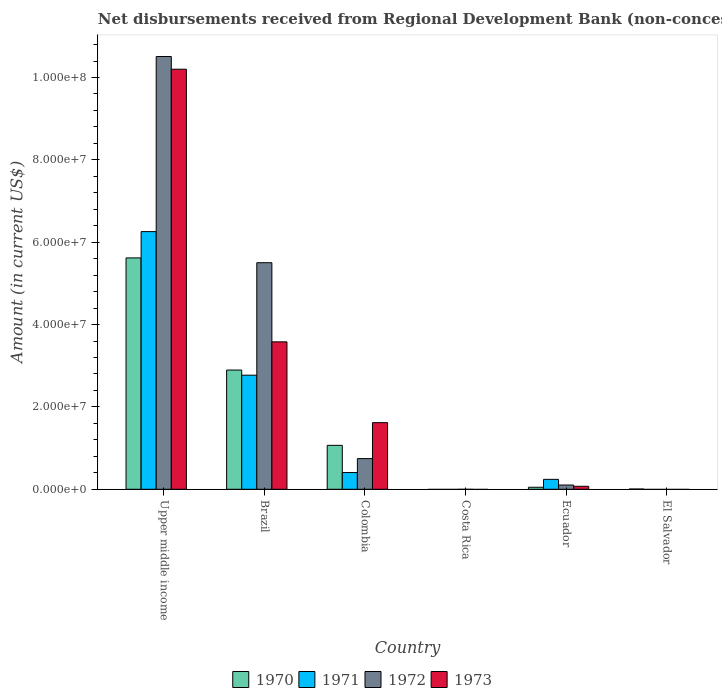Are the number of bars per tick equal to the number of legend labels?
Ensure brevity in your answer.  No. In how many cases, is the number of bars for a given country not equal to the number of legend labels?
Keep it short and to the point. 2. What is the amount of disbursements received from Regional Development Bank in 1970 in Upper middle income?
Ensure brevity in your answer.  5.62e+07. Across all countries, what is the maximum amount of disbursements received from Regional Development Bank in 1973?
Keep it short and to the point. 1.02e+08. In which country was the amount of disbursements received from Regional Development Bank in 1972 maximum?
Ensure brevity in your answer.  Upper middle income. What is the total amount of disbursements received from Regional Development Bank in 1973 in the graph?
Offer a terse response. 1.55e+08. What is the difference between the amount of disbursements received from Regional Development Bank in 1973 in Colombia and that in Ecuador?
Offer a very short reply. 1.55e+07. What is the difference between the amount of disbursements received from Regional Development Bank in 1971 in Colombia and the amount of disbursements received from Regional Development Bank in 1970 in Ecuador?
Your response must be concise. 3.57e+06. What is the average amount of disbursements received from Regional Development Bank in 1970 per country?
Give a very brief answer. 1.61e+07. What is the difference between the amount of disbursements received from Regional Development Bank of/in 1970 and amount of disbursements received from Regional Development Bank of/in 1971 in Ecuador?
Your answer should be very brief. -1.92e+06. What is the ratio of the amount of disbursements received from Regional Development Bank in 1972 in Brazil to that in Colombia?
Keep it short and to the point. 7.39. Is the amount of disbursements received from Regional Development Bank in 1972 in Brazil less than that in Ecuador?
Ensure brevity in your answer.  No. Is the difference between the amount of disbursements received from Regional Development Bank in 1970 in Colombia and Upper middle income greater than the difference between the amount of disbursements received from Regional Development Bank in 1971 in Colombia and Upper middle income?
Keep it short and to the point. Yes. What is the difference between the highest and the second highest amount of disbursements received from Regional Development Bank in 1970?
Provide a short and direct response. 4.55e+07. What is the difference between the highest and the lowest amount of disbursements received from Regional Development Bank in 1972?
Your answer should be very brief. 1.05e+08. Is it the case that in every country, the sum of the amount of disbursements received from Regional Development Bank in 1971 and amount of disbursements received from Regional Development Bank in 1970 is greater than the amount of disbursements received from Regional Development Bank in 1972?
Ensure brevity in your answer.  No. How many bars are there?
Offer a terse response. 17. How many countries are there in the graph?
Provide a succinct answer. 6. What is the difference between two consecutive major ticks on the Y-axis?
Make the answer very short. 2.00e+07. Does the graph contain any zero values?
Keep it short and to the point. Yes. Does the graph contain grids?
Offer a very short reply. No. How many legend labels are there?
Ensure brevity in your answer.  4. How are the legend labels stacked?
Give a very brief answer. Horizontal. What is the title of the graph?
Make the answer very short. Net disbursements received from Regional Development Bank (non-concessional). What is the label or title of the Y-axis?
Provide a short and direct response. Amount (in current US$). What is the Amount (in current US$) in 1970 in Upper middle income?
Your answer should be compact. 5.62e+07. What is the Amount (in current US$) of 1971 in Upper middle income?
Ensure brevity in your answer.  6.26e+07. What is the Amount (in current US$) of 1972 in Upper middle income?
Your answer should be very brief. 1.05e+08. What is the Amount (in current US$) in 1973 in Upper middle income?
Ensure brevity in your answer.  1.02e+08. What is the Amount (in current US$) in 1970 in Brazil?
Offer a terse response. 2.90e+07. What is the Amount (in current US$) in 1971 in Brazil?
Keep it short and to the point. 2.77e+07. What is the Amount (in current US$) of 1972 in Brazil?
Keep it short and to the point. 5.50e+07. What is the Amount (in current US$) in 1973 in Brazil?
Provide a succinct answer. 3.58e+07. What is the Amount (in current US$) of 1970 in Colombia?
Ensure brevity in your answer.  1.07e+07. What is the Amount (in current US$) of 1971 in Colombia?
Offer a terse response. 4.06e+06. What is the Amount (in current US$) of 1972 in Colombia?
Your answer should be very brief. 7.45e+06. What is the Amount (in current US$) in 1973 in Colombia?
Your answer should be very brief. 1.62e+07. What is the Amount (in current US$) in 1972 in Costa Rica?
Provide a succinct answer. 0. What is the Amount (in current US$) of 1973 in Costa Rica?
Offer a very short reply. 0. What is the Amount (in current US$) of 1970 in Ecuador?
Offer a very short reply. 4.89e+05. What is the Amount (in current US$) in 1971 in Ecuador?
Provide a short and direct response. 2.41e+06. What is the Amount (in current US$) of 1972 in Ecuador?
Your response must be concise. 1.03e+06. What is the Amount (in current US$) of 1973 in Ecuador?
Make the answer very short. 7.26e+05. What is the Amount (in current US$) in 1970 in El Salvador?
Offer a very short reply. 5.70e+04. What is the Amount (in current US$) of 1973 in El Salvador?
Your response must be concise. 0. Across all countries, what is the maximum Amount (in current US$) in 1970?
Your answer should be compact. 5.62e+07. Across all countries, what is the maximum Amount (in current US$) in 1971?
Offer a very short reply. 6.26e+07. Across all countries, what is the maximum Amount (in current US$) of 1972?
Make the answer very short. 1.05e+08. Across all countries, what is the maximum Amount (in current US$) of 1973?
Your answer should be compact. 1.02e+08. Across all countries, what is the minimum Amount (in current US$) of 1971?
Offer a terse response. 0. What is the total Amount (in current US$) of 1970 in the graph?
Your answer should be compact. 9.64e+07. What is the total Amount (in current US$) of 1971 in the graph?
Provide a short and direct response. 9.68e+07. What is the total Amount (in current US$) in 1972 in the graph?
Your answer should be compact. 1.69e+08. What is the total Amount (in current US$) of 1973 in the graph?
Your answer should be compact. 1.55e+08. What is the difference between the Amount (in current US$) in 1970 in Upper middle income and that in Brazil?
Provide a succinct answer. 2.72e+07. What is the difference between the Amount (in current US$) of 1971 in Upper middle income and that in Brazil?
Your answer should be very brief. 3.49e+07. What is the difference between the Amount (in current US$) in 1972 in Upper middle income and that in Brazil?
Your response must be concise. 5.01e+07. What is the difference between the Amount (in current US$) of 1973 in Upper middle income and that in Brazil?
Make the answer very short. 6.62e+07. What is the difference between the Amount (in current US$) of 1970 in Upper middle income and that in Colombia?
Make the answer very short. 4.55e+07. What is the difference between the Amount (in current US$) of 1971 in Upper middle income and that in Colombia?
Make the answer very short. 5.85e+07. What is the difference between the Amount (in current US$) in 1972 in Upper middle income and that in Colombia?
Provide a short and direct response. 9.76e+07. What is the difference between the Amount (in current US$) in 1973 in Upper middle income and that in Colombia?
Your answer should be very brief. 8.58e+07. What is the difference between the Amount (in current US$) of 1970 in Upper middle income and that in Ecuador?
Your answer should be very brief. 5.57e+07. What is the difference between the Amount (in current US$) in 1971 in Upper middle income and that in Ecuador?
Your answer should be compact. 6.02e+07. What is the difference between the Amount (in current US$) in 1972 in Upper middle income and that in Ecuador?
Your answer should be very brief. 1.04e+08. What is the difference between the Amount (in current US$) in 1973 in Upper middle income and that in Ecuador?
Give a very brief answer. 1.01e+08. What is the difference between the Amount (in current US$) of 1970 in Upper middle income and that in El Salvador?
Your answer should be very brief. 5.61e+07. What is the difference between the Amount (in current US$) in 1970 in Brazil and that in Colombia?
Provide a short and direct response. 1.83e+07. What is the difference between the Amount (in current US$) in 1971 in Brazil and that in Colombia?
Ensure brevity in your answer.  2.36e+07. What is the difference between the Amount (in current US$) in 1972 in Brazil and that in Colombia?
Your answer should be compact. 4.76e+07. What is the difference between the Amount (in current US$) in 1973 in Brazil and that in Colombia?
Offer a very short reply. 1.96e+07. What is the difference between the Amount (in current US$) in 1970 in Brazil and that in Ecuador?
Make the answer very short. 2.85e+07. What is the difference between the Amount (in current US$) of 1971 in Brazil and that in Ecuador?
Your response must be concise. 2.53e+07. What is the difference between the Amount (in current US$) of 1972 in Brazil and that in Ecuador?
Offer a very short reply. 5.40e+07. What is the difference between the Amount (in current US$) in 1973 in Brazil and that in Ecuador?
Ensure brevity in your answer.  3.51e+07. What is the difference between the Amount (in current US$) of 1970 in Brazil and that in El Salvador?
Your answer should be very brief. 2.89e+07. What is the difference between the Amount (in current US$) of 1970 in Colombia and that in Ecuador?
Make the answer very short. 1.02e+07. What is the difference between the Amount (in current US$) in 1971 in Colombia and that in Ecuador?
Provide a short and direct response. 1.65e+06. What is the difference between the Amount (in current US$) in 1972 in Colombia and that in Ecuador?
Keep it short and to the point. 6.42e+06. What is the difference between the Amount (in current US$) of 1973 in Colombia and that in Ecuador?
Provide a short and direct response. 1.55e+07. What is the difference between the Amount (in current US$) in 1970 in Colombia and that in El Salvador?
Provide a succinct answer. 1.06e+07. What is the difference between the Amount (in current US$) in 1970 in Ecuador and that in El Salvador?
Give a very brief answer. 4.32e+05. What is the difference between the Amount (in current US$) of 1970 in Upper middle income and the Amount (in current US$) of 1971 in Brazil?
Provide a succinct answer. 2.85e+07. What is the difference between the Amount (in current US$) of 1970 in Upper middle income and the Amount (in current US$) of 1972 in Brazil?
Offer a terse response. 1.16e+06. What is the difference between the Amount (in current US$) of 1970 in Upper middle income and the Amount (in current US$) of 1973 in Brazil?
Give a very brief answer. 2.04e+07. What is the difference between the Amount (in current US$) of 1971 in Upper middle income and the Amount (in current US$) of 1972 in Brazil?
Your response must be concise. 7.55e+06. What is the difference between the Amount (in current US$) in 1971 in Upper middle income and the Amount (in current US$) in 1973 in Brazil?
Keep it short and to the point. 2.68e+07. What is the difference between the Amount (in current US$) of 1972 in Upper middle income and the Amount (in current US$) of 1973 in Brazil?
Offer a very short reply. 6.93e+07. What is the difference between the Amount (in current US$) of 1970 in Upper middle income and the Amount (in current US$) of 1971 in Colombia?
Provide a succinct answer. 5.21e+07. What is the difference between the Amount (in current US$) in 1970 in Upper middle income and the Amount (in current US$) in 1972 in Colombia?
Make the answer very short. 4.87e+07. What is the difference between the Amount (in current US$) of 1970 in Upper middle income and the Amount (in current US$) of 1973 in Colombia?
Keep it short and to the point. 4.00e+07. What is the difference between the Amount (in current US$) in 1971 in Upper middle income and the Amount (in current US$) in 1972 in Colombia?
Give a very brief answer. 5.51e+07. What is the difference between the Amount (in current US$) in 1971 in Upper middle income and the Amount (in current US$) in 1973 in Colombia?
Make the answer very short. 4.64e+07. What is the difference between the Amount (in current US$) of 1972 in Upper middle income and the Amount (in current US$) of 1973 in Colombia?
Your answer should be compact. 8.89e+07. What is the difference between the Amount (in current US$) in 1970 in Upper middle income and the Amount (in current US$) in 1971 in Ecuador?
Your response must be concise. 5.38e+07. What is the difference between the Amount (in current US$) in 1970 in Upper middle income and the Amount (in current US$) in 1972 in Ecuador?
Offer a terse response. 5.52e+07. What is the difference between the Amount (in current US$) in 1970 in Upper middle income and the Amount (in current US$) in 1973 in Ecuador?
Provide a succinct answer. 5.55e+07. What is the difference between the Amount (in current US$) in 1971 in Upper middle income and the Amount (in current US$) in 1972 in Ecuador?
Provide a succinct answer. 6.15e+07. What is the difference between the Amount (in current US$) of 1971 in Upper middle income and the Amount (in current US$) of 1973 in Ecuador?
Offer a terse response. 6.18e+07. What is the difference between the Amount (in current US$) in 1972 in Upper middle income and the Amount (in current US$) in 1973 in Ecuador?
Your answer should be compact. 1.04e+08. What is the difference between the Amount (in current US$) of 1970 in Brazil and the Amount (in current US$) of 1971 in Colombia?
Your answer should be very brief. 2.49e+07. What is the difference between the Amount (in current US$) of 1970 in Brazil and the Amount (in current US$) of 1972 in Colombia?
Your response must be concise. 2.15e+07. What is the difference between the Amount (in current US$) of 1970 in Brazil and the Amount (in current US$) of 1973 in Colombia?
Provide a succinct answer. 1.28e+07. What is the difference between the Amount (in current US$) in 1971 in Brazil and the Amount (in current US$) in 1972 in Colombia?
Offer a terse response. 2.03e+07. What is the difference between the Amount (in current US$) in 1971 in Brazil and the Amount (in current US$) in 1973 in Colombia?
Provide a short and direct response. 1.15e+07. What is the difference between the Amount (in current US$) in 1972 in Brazil and the Amount (in current US$) in 1973 in Colombia?
Give a very brief answer. 3.88e+07. What is the difference between the Amount (in current US$) in 1970 in Brazil and the Amount (in current US$) in 1971 in Ecuador?
Provide a short and direct response. 2.65e+07. What is the difference between the Amount (in current US$) in 1970 in Brazil and the Amount (in current US$) in 1972 in Ecuador?
Give a very brief answer. 2.79e+07. What is the difference between the Amount (in current US$) of 1970 in Brazil and the Amount (in current US$) of 1973 in Ecuador?
Keep it short and to the point. 2.82e+07. What is the difference between the Amount (in current US$) in 1971 in Brazil and the Amount (in current US$) in 1972 in Ecuador?
Provide a short and direct response. 2.67e+07. What is the difference between the Amount (in current US$) of 1971 in Brazil and the Amount (in current US$) of 1973 in Ecuador?
Ensure brevity in your answer.  2.70e+07. What is the difference between the Amount (in current US$) of 1972 in Brazil and the Amount (in current US$) of 1973 in Ecuador?
Make the answer very short. 5.43e+07. What is the difference between the Amount (in current US$) in 1970 in Colombia and the Amount (in current US$) in 1971 in Ecuador?
Your answer should be very brief. 8.26e+06. What is the difference between the Amount (in current US$) of 1970 in Colombia and the Amount (in current US$) of 1972 in Ecuador?
Keep it short and to the point. 9.64e+06. What is the difference between the Amount (in current US$) in 1970 in Colombia and the Amount (in current US$) in 1973 in Ecuador?
Offer a very short reply. 9.94e+06. What is the difference between the Amount (in current US$) of 1971 in Colombia and the Amount (in current US$) of 1972 in Ecuador?
Your answer should be very brief. 3.03e+06. What is the difference between the Amount (in current US$) in 1971 in Colombia and the Amount (in current US$) in 1973 in Ecuador?
Provide a succinct answer. 3.34e+06. What is the difference between the Amount (in current US$) of 1972 in Colombia and the Amount (in current US$) of 1973 in Ecuador?
Your response must be concise. 6.72e+06. What is the average Amount (in current US$) of 1970 per country?
Your response must be concise. 1.61e+07. What is the average Amount (in current US$) of 1971 per country?
Offer a terse response. 1.61e+07. What is the average Amount (in current US$) in 1972 per country?
Your response must be concise. 2.81e+07. What is the average Amount (in current US$) in 1973 per country?
Your answer should be compact. 2.58e+07. What is the difference between the Amount (in current US$) in 1970 and Amount (in current US$) in 1971 in Upper middle income?
Ensure brevity in your answer.  -6.39e+06. What is the difference between the Amount (in current US$) of 1970 and Amount (in current US$) of 1972 in Upper middle income?
Offer a very short reply. -4.89e+07. What is the difference between the Amount (in current US$) in 1970 and Amount (in current US$) in 1973 in Upper middle income?
Ensure brevity in your answer.  -4.58e+07. What is the difference between the Amount (in current US$) of 1971 and Amount (in current US$) of 1972 in Upper middle income?
Make the answer very short. -4.25e+07. What is the difference between the Amount (in current US$) in 1971 and Amount (in current US$) in 1973 in Upper middle income?
Your answer should be very brief. -3.94e+07. What is the difference between the Amount (in current US$) in 1972 and Amount (in current US$) in 1973 in Upper middle income?
Provide a short and direct response. 3.08e+06. What is the difference between the Amount (in current US$) in 1970 and Amount (in current US$) in 1971 in Brazil?
Give a very brief answer. 1.25e+06. What is the difference between the Amount (in current US$) in 1970 and Amount (in current US$) in 1972 in Brazil?
Provide a short and direct response. -2.61e+07. What is the difference between the Amount (in current US$) in 1970 and Amount (in current US$) in 1973 in Brazil?
Your answer should be compact. -6.85e+06. What is the difference between the Amount (in current US$) in 1971 and Amount (in current US$) in 1972 in Brazil?
Give a very brief answer. -2.73e+07. What is the difference between the Amount (in current US$) of 1971 and Amount (in current US$) of 1973 in Brazil?
Keep it short and to the point. -8.10e+06. What is the difference between the Amount (in current US$) of 1972 and Amount (in current US$) of 1973 in Brazil?
Your response must be concise. 1.92e+07. What is the difference between the Amount (in current US$) in 1970 and Amount (in current US$) in 1971 in Colombia?
Provide a succinct answer. 6.61e+06. What is the difference between the Amount (in current US$) of 1970 and Amount (in current US$) of 1972 in Colombia?
Make the answer very short. 3.22e+06. What is the difference between the Amount (in current US$) of 1970 and Amount (in current US$) of 1973 in Colombia?
Provide a succinct answer. -5.51e+06. What is the difference between the Amount (in current US$) in 1971 and Amount (in current US$) in 1972 in Colombia?
Give a very brief answer. -3.39e+06. What is the difference between the Amount (in current US$) in 1971 and Amount (in current US$) in 1973 in Colombia?
Provide a succinct answer. -1.21e+07. What is the difference between the Amount (in current US$) of 1972 and Amount (in current US$) of 1973 in Colombia?
Make the answer very short. -8.73e+06. What is the difference between the Amount (in current US$) in 1970 and Amount (in current US$) in 1971 in Ecuador?
Provide a succinct answer. -1.92e+06. What is the difference between the Amount (in current US$) in 1970 and Amount (in current US$) in 1972 in Ecuador?
Your response must be concise. -5.42e+05. What is the difference between the Amount (in current US$) of 1970 and Amount (in current US$) of 1973 in Ecuador?
Your answer should be very brief. -2.37e+05. What is the difference between the Amount (in current US$) of 1971 and Amount (in current US$) of 1972 in Ecuador?
Give a very brief answer. 1.38e+06. What is the difference between the Amount (in current US$) of 1971 and Amount (in current US$) of 1973 in Ecuador?
Provide a succinct answer. 1.68e+06. What is the difference between the Amount (in current US$) of 1972 and Amount (in current US$) of 1973 in Ecuador?
Offer a terse response. 3.05e+05. What is the ratio of the Amount (in current US$) of 1970 in Upper middle income to that in Brazil?
Your answer should be very brief. 1.94. What is the ratio of the Amount (in current US$) in 1971 in Upper middle income to that in Brazil?
Ensure brevity in your answer.  2.26. What is the ratio of the Amount (in current US$) in 1972 in Upper middle income to that in Brazil?
Your answer should be compact. 1.91. What is the ratio of the Amount (in current US$) in 1973 in Upper middle income to that in Brazil?
Provide a succinct answer. 2.85. What is the ratio of the Amount (in current US$) of 1970 in Upper middle income to that in Colombia?
Make the answer very short. 5.27. What is the ratio of the Amount (in current US$) in 1971 in Upper middle income to that in Colombia?
Make the answer very short. 15.4. What is the ratio of the Amount (in current US$) of 1972 in Upper middle income to that in Colombia?
Give a very brief answer. 14.11. What is the ratio of the Amount (in current US$) in 1973 in Upper middle income to that in Colombia?
Provide a succinct answer. 6.3. What is the ratio of the Amount (in current US$) of 1970 in Upper middle income to that in Ecuador?
Your response must be concise. 114.9. What is the ratio of the Amount (in current US$) in 1971 in Upper middle income to that in Ecuador?
Give a very brief answer. 25.95. What is the ratio of the Amount (in current US$) of 1972 in Upper middle income to that in Ecuador?
Your answer should be compact. 101.94. What is the ratio of the Amount (in current US$) of 1973 in Upper middle income to that in Ecuador?
Make the answer very short. 140.52. What is the ratio of the Amount (in current US$) in 1970 in Upper middle income to that in El Salvador?
Provide a short and direct response. 985.7. What is the ratio of the Amount (in current US$) in 1970 in Brazil to that in Colombia?
Provide a short and direct response. 2.71. What is the ratio of the Amount (in current US$) in 1971 in Brazil to that in Colombia?
Keep it short and to the point. 6.82. What is the ratio of the Amount (in current US$) of 1972 in Brazil to that in Colombia?
Offer a terse response. 7.39. What is the ratio of the Amount (in current US$) in 1973 in Brazil to that in Colombia?
Keep it short and to the point. 2.21. What is the ratio of the Amount (in current US$) in 1970 in Brazil to that in Ecuador?
Give a very brief answer. 59.21. What is the ratio of the Amount (in current US$) in 1971 in Brazil to that in Ecuador?
Offer a terse response. 11.49. What is the ratio of the Amount (in current US$) of 1972 in Brazil to that in Ecuador?
Offer a very short reply. 53.37. What is the ratio of the Amount (in current US$) in 1973 in Brazil to that in Ecuador?
Offer a very short reply. 49.31. What is the ratio of the Amount (in current US$) in 1970 in Brazil to that in El Salvador?
Provide a succinct answer. 507.93. What is the ratio of the Amount (in current US$) in 1970 in Colombia to that in Ecuador?
Your answer should be compact. 21.82. What is the ratio of the Amount (in current US$) in 1971 in Colombia to that in Ecuador?
Provide a short and direct response. 1.68. What is the ratio of the Amount (in current US$) of 1972 in Colombia to that in Ecuador?
Provide a short and direct response. 7.23. What is the ratio of the Amount (in current US$) in 1973 in Colombia to that in Ecuador?
Offer a very short reply. 22.29. What is the ratio of the Amount (in current US$) of 1970 in Colombia to that in El Salvador?
Provide a succinct answer. 187.19. What is the ratio of the Amount (in current US$) in 1970 in Ecuador to that in El Salvador?
Your answer should be very brief. 8.58. What is the difference between the highest and the second highest Amount (in current US$) of 1970?
Your response must be concise. 2.72e+07. What is the difference between the highest and the second highest Amount (in current US$) in 1971?
Provide a succinct answer. 3.49e+07. What is the difference between the highest and the second highest Amount (in current US$) in 1972?
Your answer should be compact. 5.01e+07. What is the difference between the highest and the second highest Amount (in current US$) of 1973?
Provide a short and direct response. 6.62e+07. What is the difference between the highest and the lowest Amount (in current US$) of 1970?
Provide a short and direct response. 5.62e+07. What is the difference between the highest and the lowest Amount (in current US$) in 1971?
Make the answer very short. 6.26e+07. What is the difference between the highest and the lowest Amount (in current US$) of 1972?
Provide a succinct answer. 1.05e+08. What is the difference between the highest and the lowest Amount (in current US$) in 1973?
Offer a very short reply. 1.02e+08. 